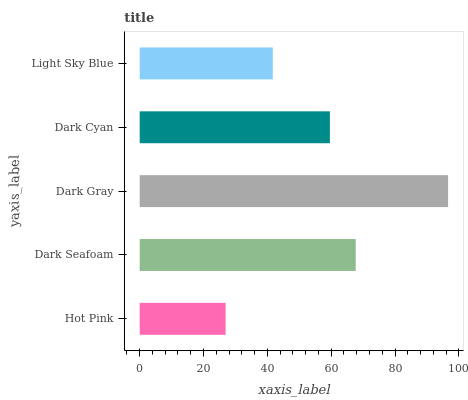Is Hot Pink the minimum?
Answer yes or no. Yes. Is Dark Gray the maximum?
Answer yes or no. Yes. Is Dark Seafoam the minimum?
Answer yes or no. No. Is Dark Seafoam the maximum?
Answer yes or no. No. Is Dark Seafoam greater than Hot Pink?
Answer yes or no. Yes. Is Hot Pink less than Dark Seafoam?
Answer yes or no. Yes. Is Hot Pink greater than Dark Seafoam?
Answer yes or no. No. Is Dark Seafoam less than Hot Pink?
Answer yes or no. No. Is Dark Cyan the high median?
Answer yes or no. Yes. Is Dark Cyan the low median?
Answer yes or no. Yes. Is Hot Pink the high median?
Answer yes or no. No. Is Hot Pink the low median?
Answer yes or no. No. 